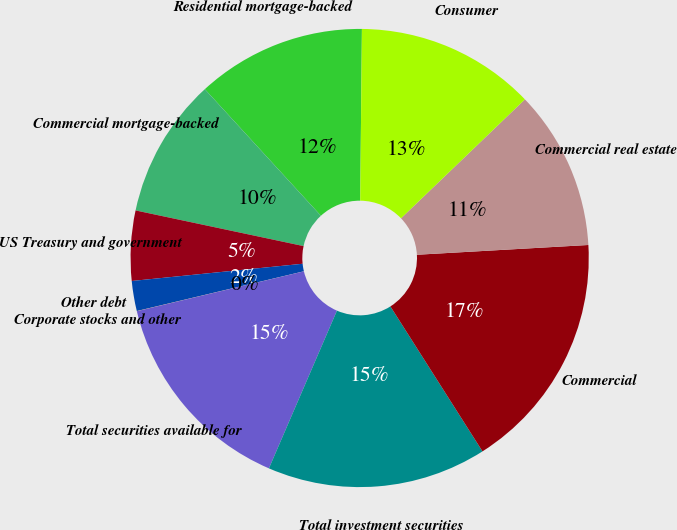Convert chart to OTSL. <chart><loc_0><loc_0><loc_500><loc_500><pie_chart><fcel>Residential mortgage-backed<fcel>Commercial mortgage-backed<fcel>US Treasury and government<fcel>Other debt<fcel>Corporate stocks and other<fcel>Total securities available for<fcel>Total investment securities<fcel>Commercial<fcel>Commercial real estate<fcel>Consumer<nl><fcel>11.97%<fcel>9.86%<fcel>4.93%<fcel>2.12%<fcel>0.01%<fcel>14.79%<fcel>15.49%<fcel>16.9%<fcel>11.27%<fcel>12.67%<nl></chart> 